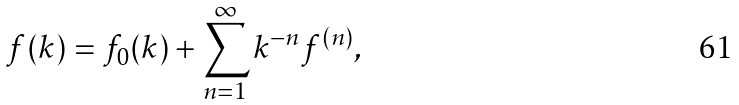<formula> <loc_0><loc_0><loc_500><loc_500>f ( k ) = f _ { 0 } ( k ) + \sum ^ { \infty } _ { n = 1 } k ^ { - n } f ^ { ( n ) } ,</formula> 